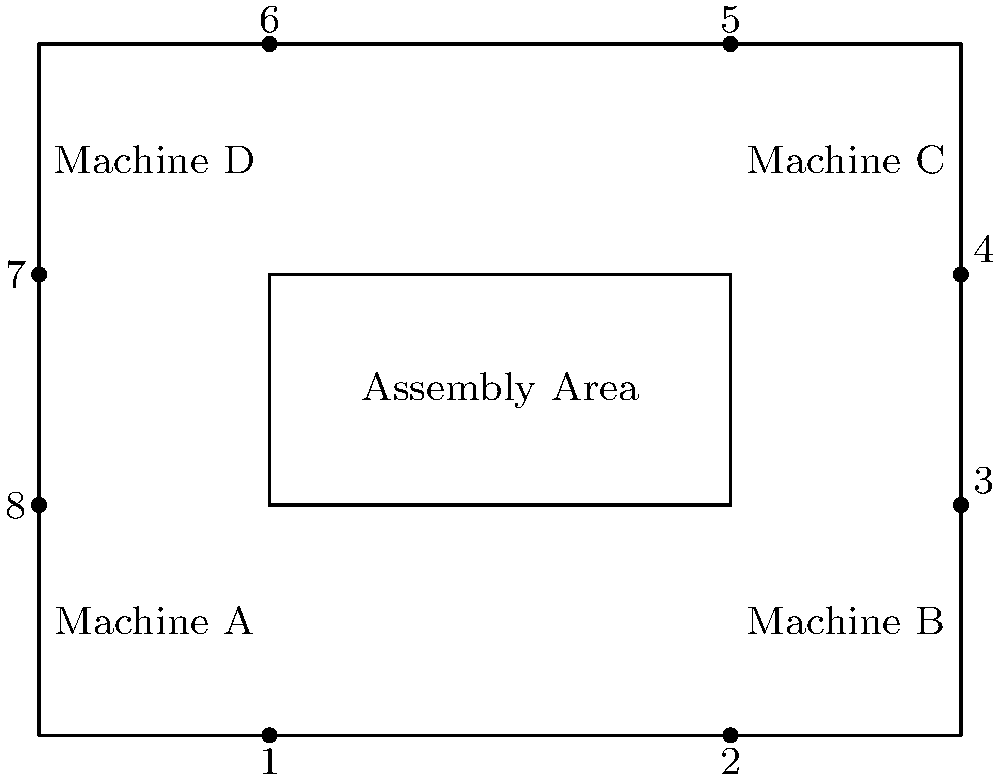In the given factory floor plan, machines A, B, C, and D are arranged around a central assembly area. To optimize the production flow, you need to determine which two machines should be swapped to minimize the total distance materials travel between machines. Which two machines should be swapped? To determine which two machines should be swapped, we need to analyze the current layout and consider the optimal flow of materials. Let's follow these steps:

1. Assume the production flow is clockwise: A → B → C → D → A.

2. Calculate the current total distance:
   A to B: 4 units
   B to C: 3 units
   C to D: 4 units
   D to A: 3 units
   Total: 14 units

3. Consider possible swaps:
   a) A and B: Total distance = 3 + 4 + 4 + 3 = 14 units (no change)
   b) A and C: Total distance = 1 + 1 + 4 + 4 = 10 units
   c) A and D: Total distance = 3 + 3 + 1 + 3 = 10 units
   d) B and C: Total distance = 4 + 1 + 3 + 4 = 12 units
   e) B and D: Total distance = 4 + 4 + 1 + 1 = 10 units
   f) C and D: Total distance = 4 + 3 + 3 + 4 = 14 units (no change)

4. The optimal arrangement is achieved by swapping either:
   - A and C
   - A and D
   - B and D

5. Among these options, swapping A and C is the most logical choice as it maintains a more balanced flow around the assembly area.

Therefore, the optimal arrangement is achieved by swapping machines A and C.
Answer: A and C 